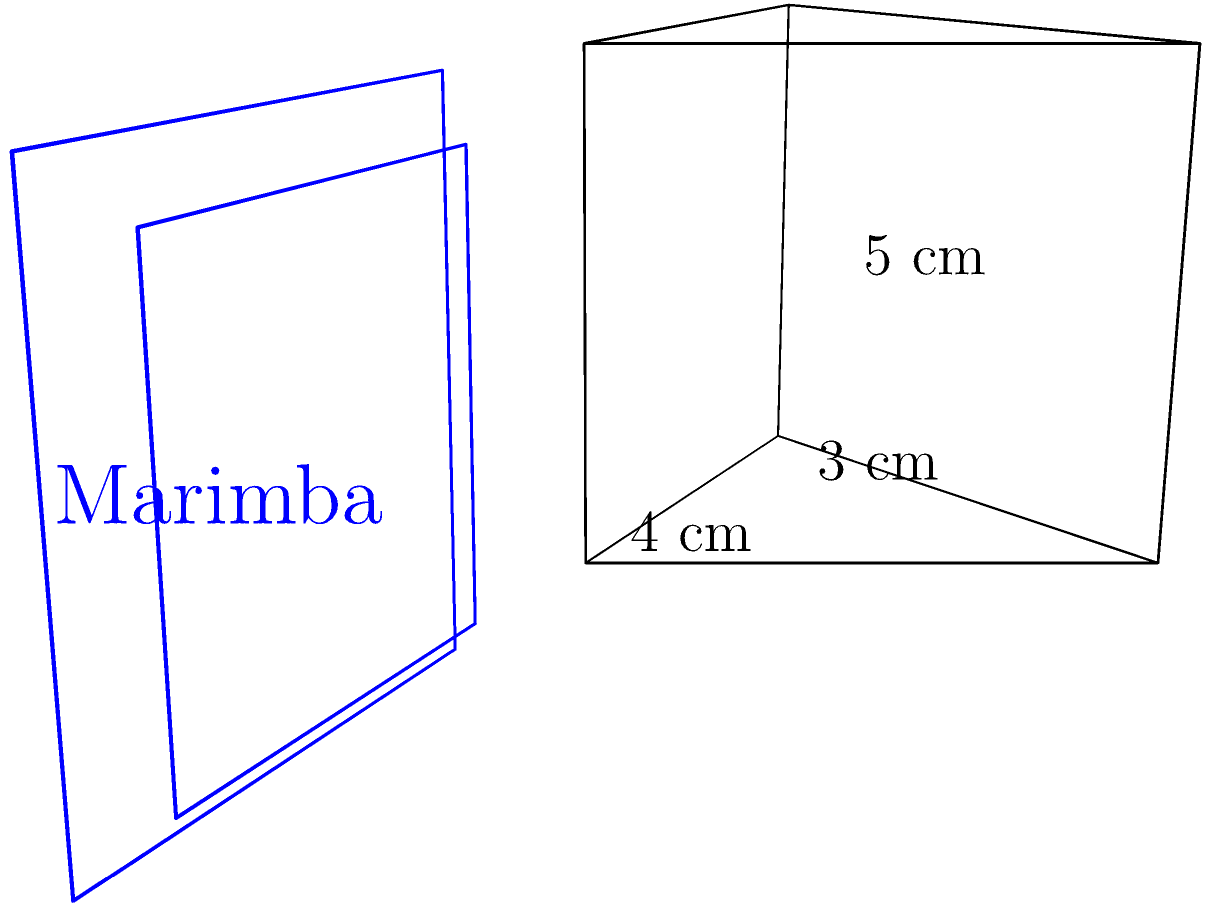A triangular prism-shaped resonator for a marimba-inspired instrument has a triangular base with a width of 4 cm and a height of 3 cm. The length of the prism is 5 cm. Calculate the volume of this resonator and compare it to the volume of a rectangular marimba resonator with dimensions 4 cm x 3 cm x 5 cm. What percentage of the rectangular resonator's volume does the triangular prism resonator occupy? Let's approach this step-by-step:

1. Calculate the area of the triangular base:
   Area of triangle = $\frac{1}{2} \times$ base $\times$ height
   $A = \frac{1}{2} \times 4 \text{ cm} \times 3 \text{ cm} = 6 \text{ cm}^2$

2. Calculate the volume of the triangular prism:
   Volume of prism = Area of base $\times$ length
   $V_{\text{prism}} = 6 \text{ cm}^2 \times 5 \text{ cm} = 30 \text{ cm}^3$

3. Calculate the volume of the rectangular marimba resonator:
   $V_{\text{rect}} = 4 \text{ cm} \times 3 \text{ cm} \times 5 \text{ cm} = 60 \text{ cm}^3$

4. Calculate the percentage of the rectangular resonator's volume that the triangular prism occupies:
   Percentage = $\frac{V_{\text{prism}}}{V_{\text{rect}}} \times 100\%$
   $= \frac{30 \text{ cm}^3}{60 \text{ cm}^3} \times 100\% = 50\%$

Therefore, the triangular prism resonator occupies 50% of the volume of the rectangular marimba resonator.
Answer: 50% 